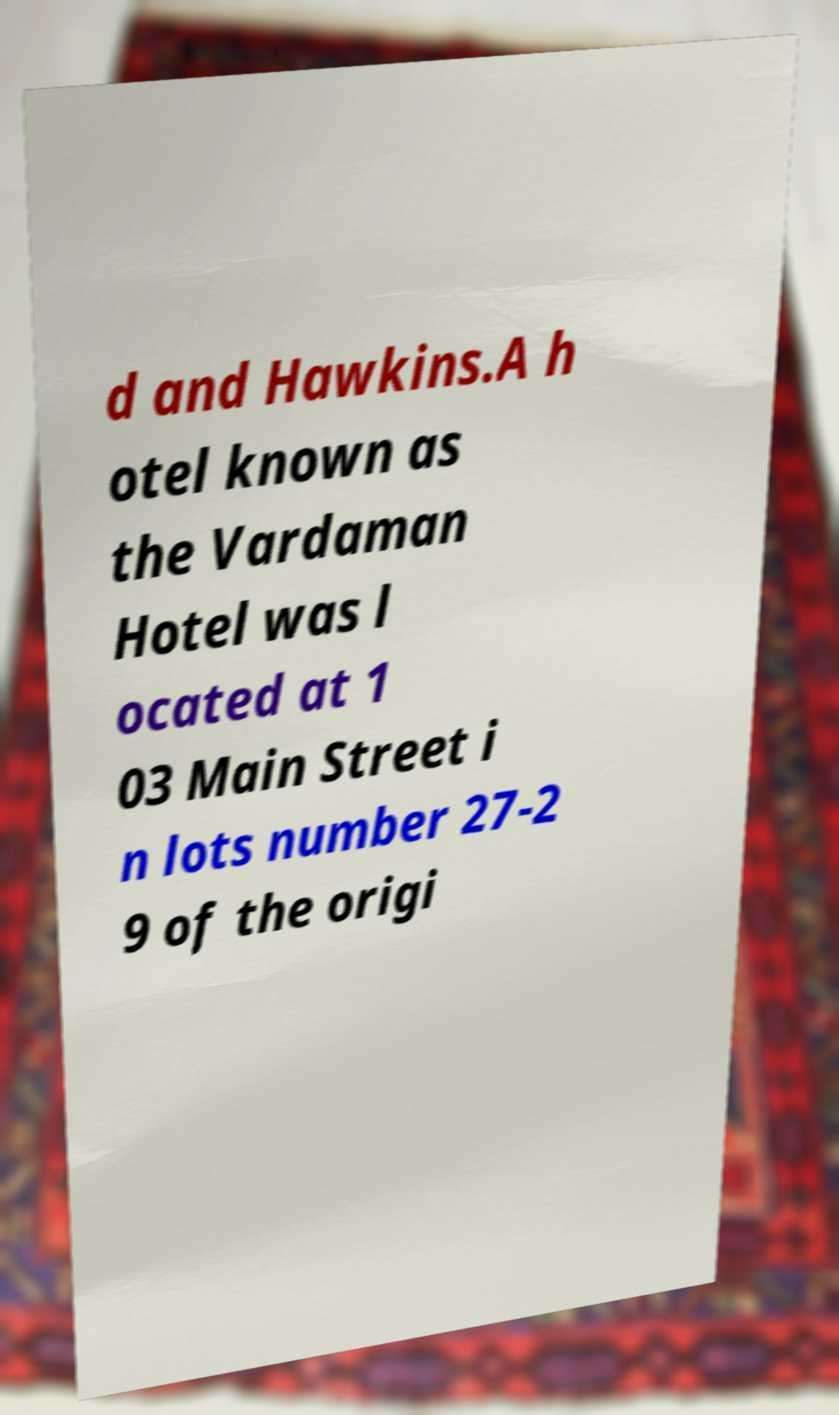Could you assist in decoding the text presented in this image and type it out clearly? d and Hawkins.A h otel known as the Vardaman Hotel was l ocated at 1 03 Main Street i n lots number 27-2 9 of the origi 